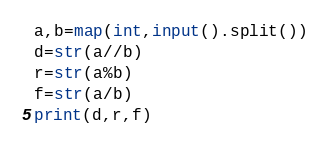Convert code to text. <code><loc_0><loc_0><loc_500><loc_500><_Python_>a,b=map(int,input().split())
d=str(a//b)
r=str(a%b)
f=str(a/b)
print(d,r,f)</code> 